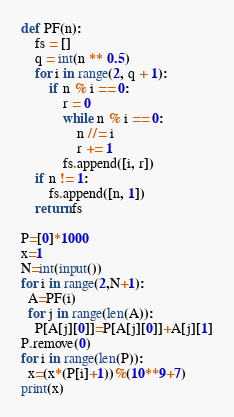<code> <loc_0><loc_0><loc_500><loc_500><_Python_>def PF(n):
    fs = []
    q = int(n ** 0.5) 
    for i in range(2, q + 1):
        if n % i == 0:
            r = 0
            while n % i == 0:
                n //= i
                r += 1
            fs.append([i, r])
    if n != 1:
        fs.append([n, 1])
    return fs

P=[0]*1000
x=1
N=int(input())
for i in range(2,N+1):
  A=PF(i)
  for j in range(len(A)):
    P[A[j][0]]=P[A[j][0]]+A[j][1]
P.remove(0)
for i in range(len(P)):
  x=(x*(P[i]+1))%(10**9+7)
print(x)</code> 